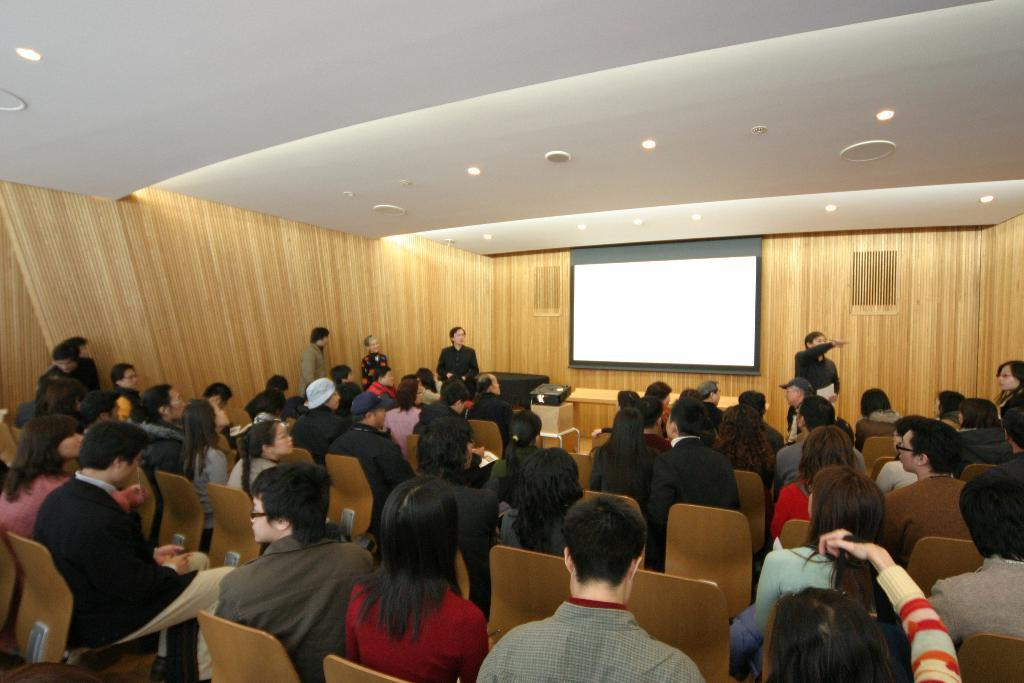What are the people in the image doing? There is a group of people sitting on chairs and a group of people standing in the image. What can be seen on the screen in the image? The facts do not specify what is on the screen, so we cannot answer that question definitively. What is used to project images onto the screen? There is a projector in the image. What type of lighting is present in the image? There are lights in the image. What piece of furniture is present in the image? There is a table in the image. What type of wall is visible in the image? There is a wooden wall in the image. What type of government is depicted in the image? There is no indication of a government in the image; it features a group of people, a screen, a projector, lights, a table, and a wooden wall. What type of sport is being played in the image? There is no sport being played in the image; it features a group of people, a screen, a projector, lights, a table, and a wooden wall. 